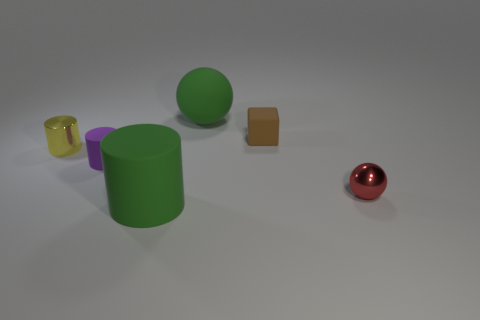Add 2 big cyan metal blocks. How many objects exist? 8 Subtract all blocks. How many objects are left? 5 Add 2 tiny balls. How many tiny balls exist? 3 Subtract 0 yellow balls. How many objects are left? 6 Subtract all matte blocks. Subtract all shiny spheres. How many objects are left? 4 Add 6 red spheres. How many red spheres are left? 7 